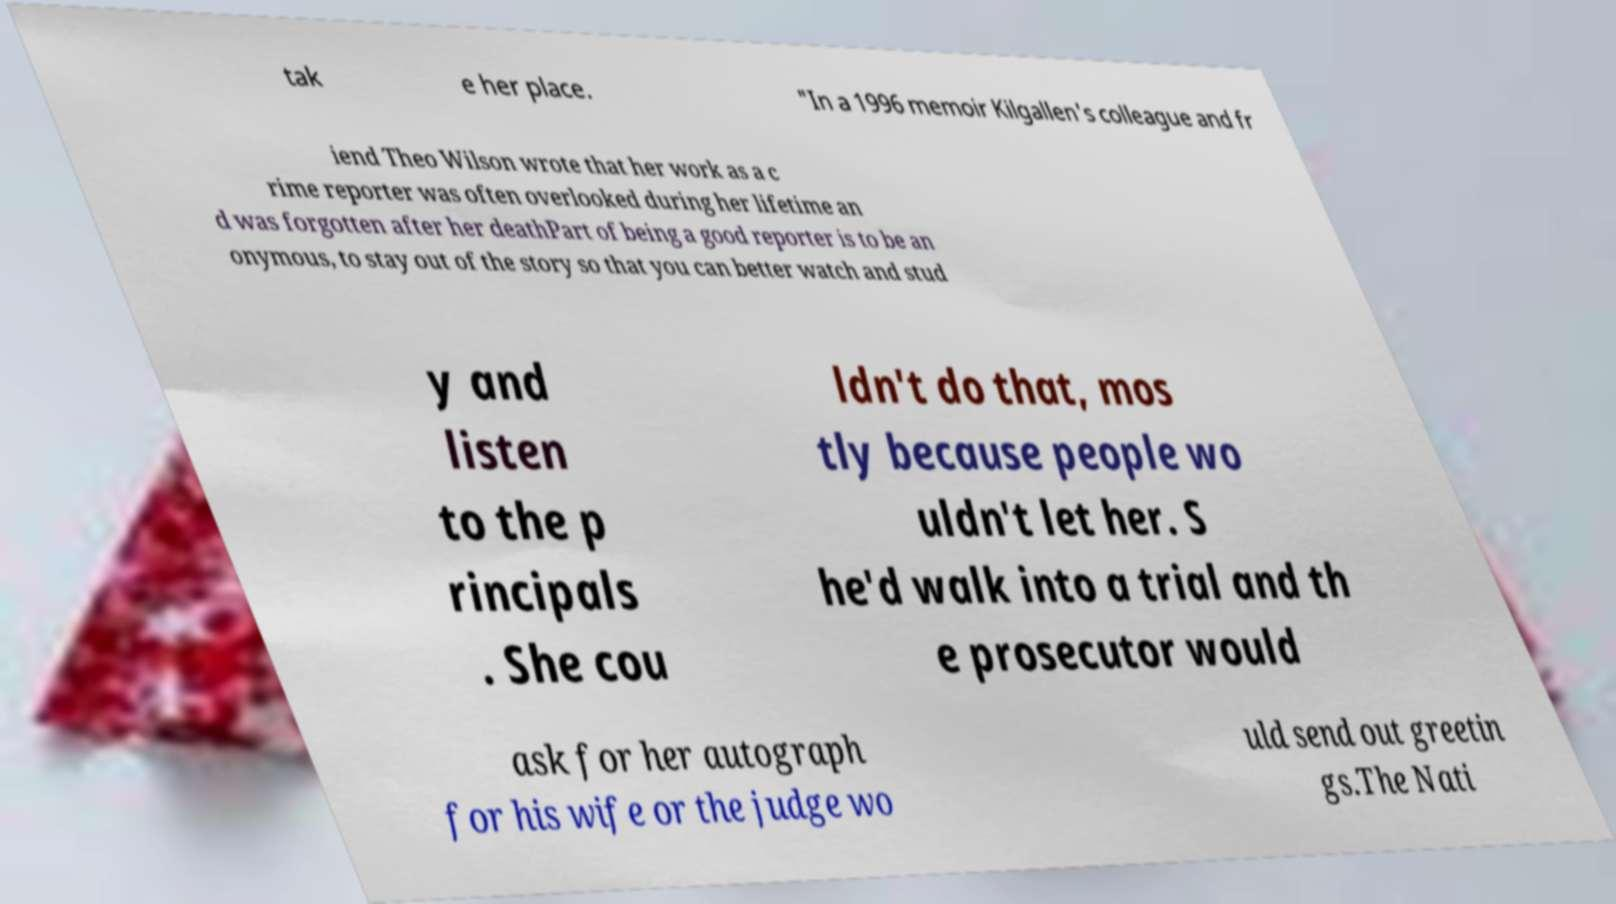There's text embedded in this image that I need extracted. Can you transcribe it verbatim? tak e her place. "In a 1996 memoir Kilgallen's colleague and fr iend Theo Wilson wrote that her work as a c rime reporter was often overlooked during her lifetime an d was forgotten after her deathPart of being a good reporter is to be an onymous, to stay out of the story so that you can better watch and stud y and listen to the p rincipals . She cou ldn't do that, mos tly because people wo uldn't let her. S he'd walk into a trial and th e prosecutor would ask for her autograph for his wife or the judge wo uld send out greetin gs.The Nati 